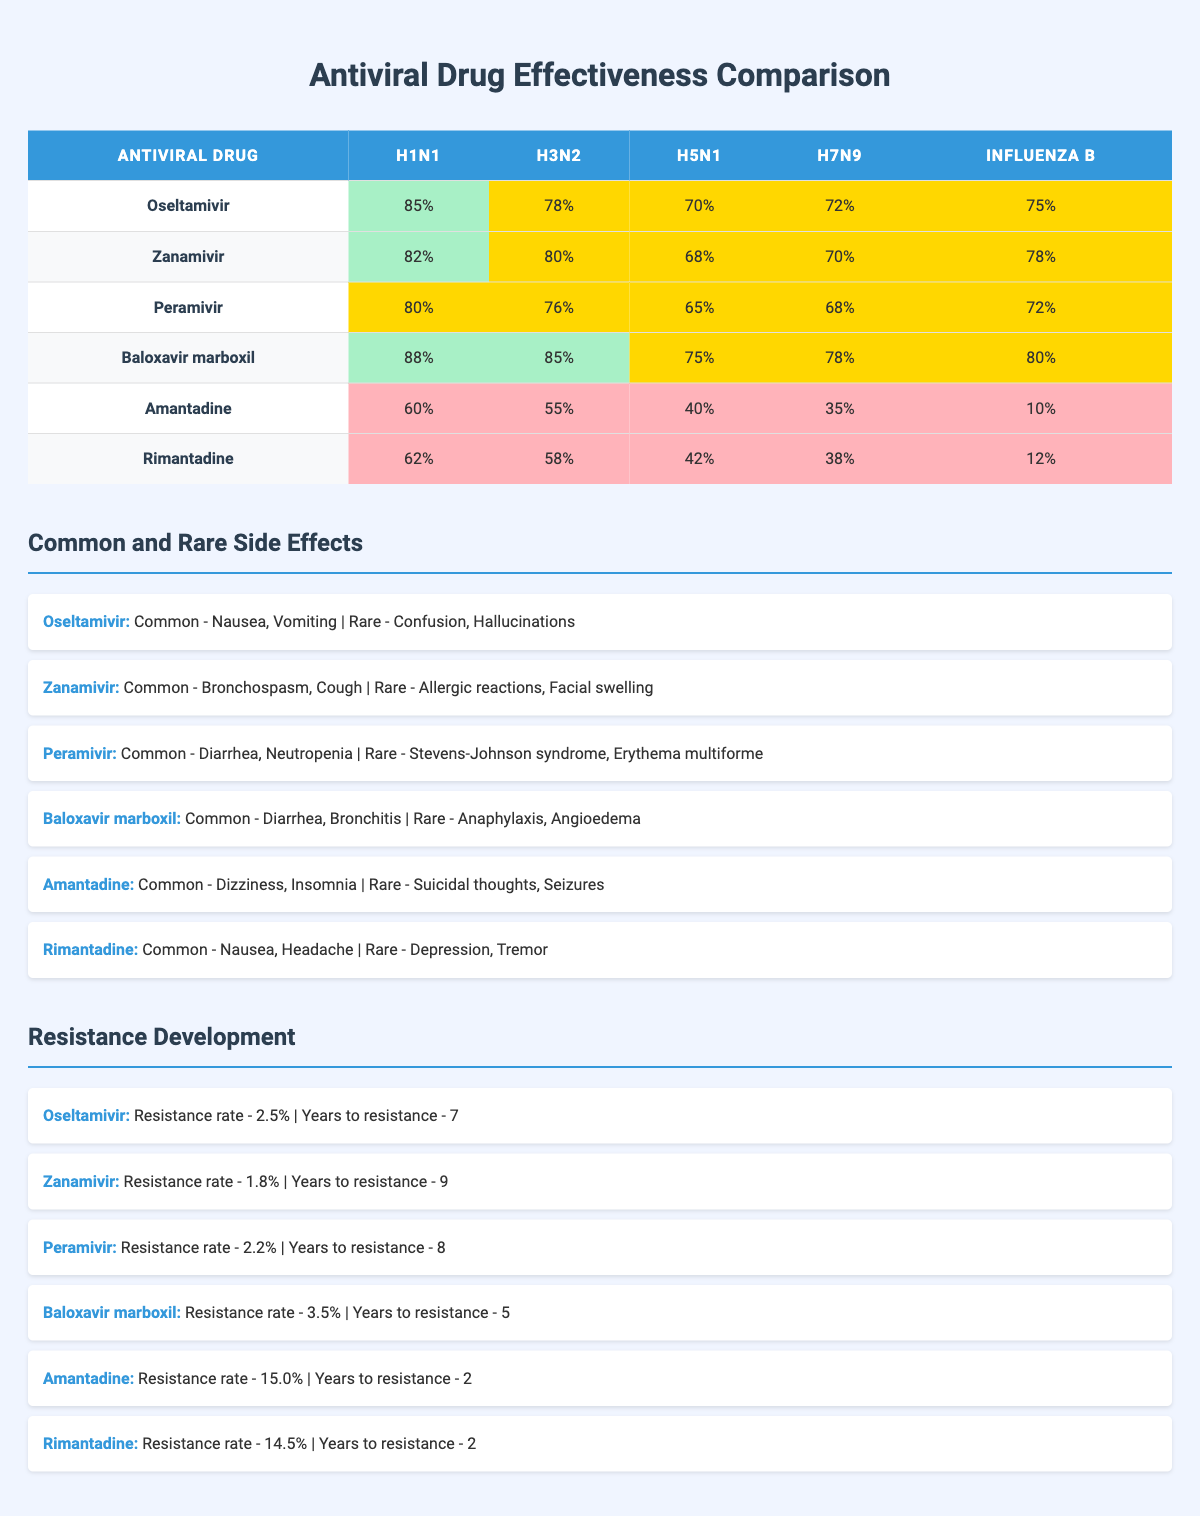What is the effectiveness of Baloxavir marboxil against H1N1? The effectiveness of Baloxavir marboxil against H1N1 is listed directly in the table as 88%.
Answer: 88% Which antiviral drug shows the highest effectiveness against Influenza B? Comparing the effectiveness percentages for Influenza B, Baloxavir marboxil has the highest effectiveness at 80%, followed by Zanamivir at 78%. Therefore, Baloxavir marboxil is the drug with the highest effectiveness against Influenza B.
Answer: Baloxavir marboxil What is the difference in effectiveness against H3N2 between Oseltamivir and Peramivir? The effectiveness percentage for Oseltamivir against H3N2 is 78%, while for Peramivir, it is 76%. The difference is calculated as 78% - 76% = 2%.
Answer: 2% Is it true that Amantadine has a lower effectiveness against H5N1 than Rimantadine? The table shows Amantadine's effectiveness against H5N1 as 40% and Rimantadine's as 42%. Since 40% is less than 42%, the statement is true.
Answer: True What is the average effectiveness of all the antiviral drugs against the H1N1 strain? To calculate the average effectiveness against H1N1, sum the effectiveness values (85 + 82 + 80 + 88 + 60 + 62) = 457. Since there are 6 drugs, divide 457 by 6, yielding approximately 76.17%.
Answer: 76.17% 